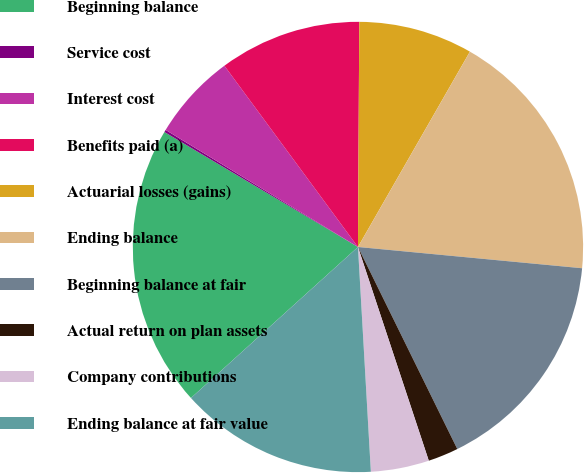Convert chart to OTSL. <chart><loc_0><loc_0><loc_500><loc_500><pie_chart><fcel>Beginning balance<fcel>Service cost<fcel>Interest cost<fcel>Benefits paid (a)<fcel>Actuarial losses (gains)<fcel>Ending balance<fcel>Beginning balance at fair<fcel>Actual return on plan assets<fcel>Company contributions<fcel>Ending balance at fair value<nl><fcel>20.23%<fcel>0.17%<fcel>6.19%<fcel>10.2%<fcel>8.19%<fcel>18.22%<fcel>16.22%<fcel>2.18%<fcel>4.18%<fcel>14.21%<nl></chart> 